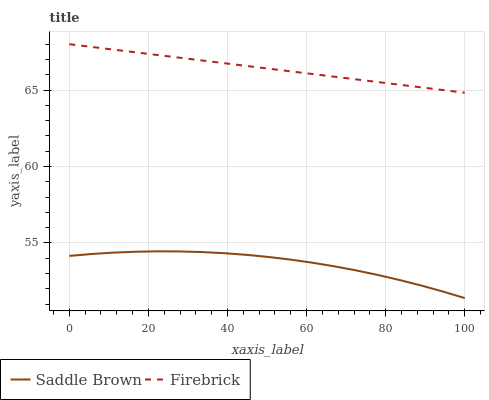Does Saddle Brown have the minimum area under the curve?
Answer yes or no. Yes. Does Firebrick have the maximum area under the curve?
Answer yes or no. Yes. Does Saddle Brown have the maximum area under the curve?
Answer yes or no. No. Is Firebrick the smoothest?
Answer yes or no. Yes. Is Saddle Brown the roughest?
Answer yes or no. Yes. Is Saddle Brown the smoothest?
Answer yes or no. No. Does Saddle Brown have the lowest value?
Answer yes or no. Yes. Does Firebrick have the highest value?
Answer yes or no. Yes. Does Saddle Brown have the highest value?
Answer yes or no. No. Is Saddle Brown less than Firebrick?
Answer yes or no. Yes. Is Firebrick greater than Saddle Brown?
Answer yes or no. Yes. Does Saddle Brown intersect Firebrick?
Answer yes or no. No. 